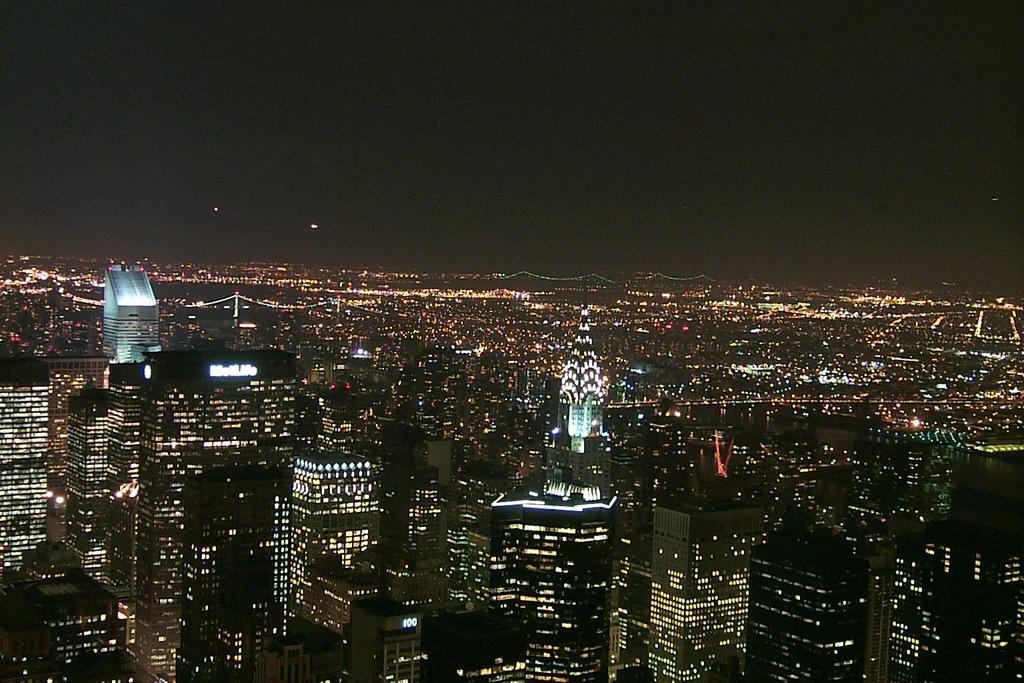What type of view is shown in the image? The image is an aerial view of the city. What structures can be seen in the image? There are buildings and towers in the image. What additional feature can be observed in the trees? The trees have lights in the image. What color is the top part of the image? The top of the image appears to be black in color. What type of toys are scattered on the ground in the image? There are no toys visible in the image; it is an aerial view of the city with buildings, towers, and trees with lights. 